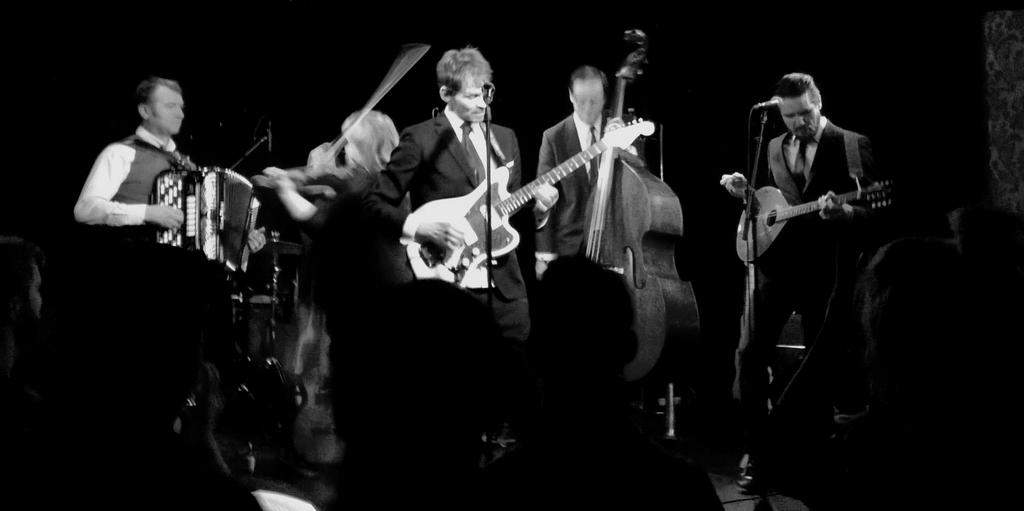What are the people in the image doing? The people in the image are standing and holding musical instruments. What objects are present that might be used for amplifying sound? There are microphones visible in the image. Are there any other people in the image besides the ones holding musical instruments? Yes, there are additional people in the image. What type of development is taking place in the image? There is no development project or construction site visible in the image; it features people holding musical instruments and microphones. What kind of engine can be seen powering a vehicle in the image? There is no vehicle or engine present in the image. 